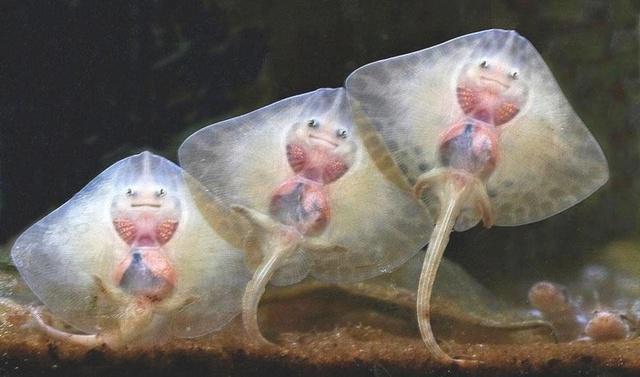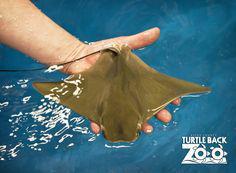The first image is the image on the left, the second image is the image on the right. Considering the images on both sides, is "There are no more than 3 sting rays total." valid? Answer yes or no. No. The first image is the image on the left, the second image is the image on the right. For the images displayed, is the sentence "Has atleast one image with more than 2 stingrays" factually correct? Answer yes or no. Yes. 